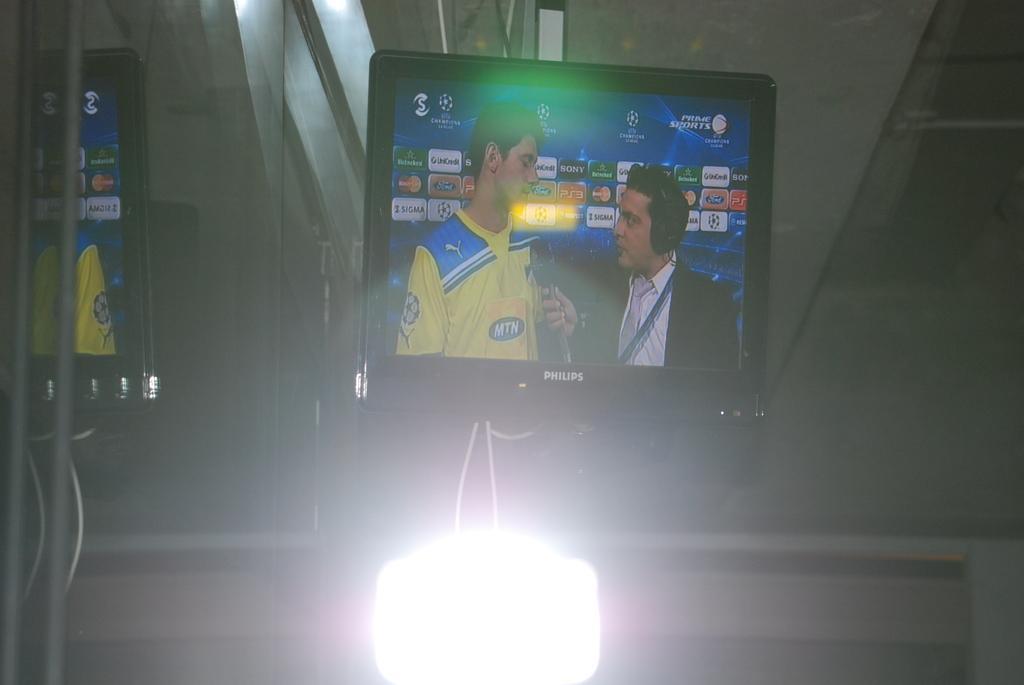<image>
Relay a brief, clear account of the picture shown. An interview is being broadcast on a large Philips monitor. 